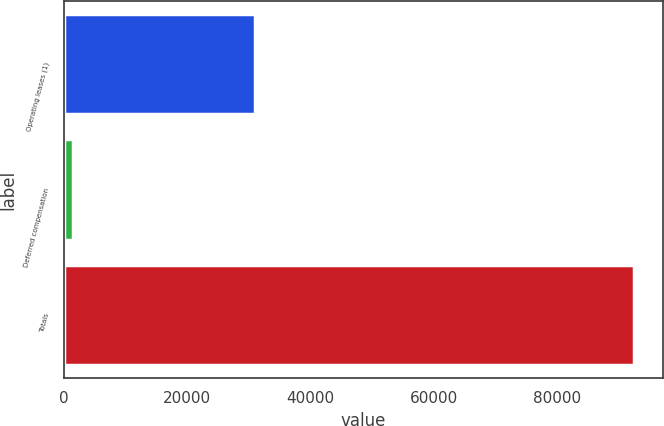Convert chart to OTSL. <chart><loc_0><loc_0><loc_500><loc_500><bar_chart><fcel>Operating leases (1)<fcel>Deferred compensation<fcel>Totals<nl><fcel>30980<fcel>1469<fcel>92505<nl></chart> 